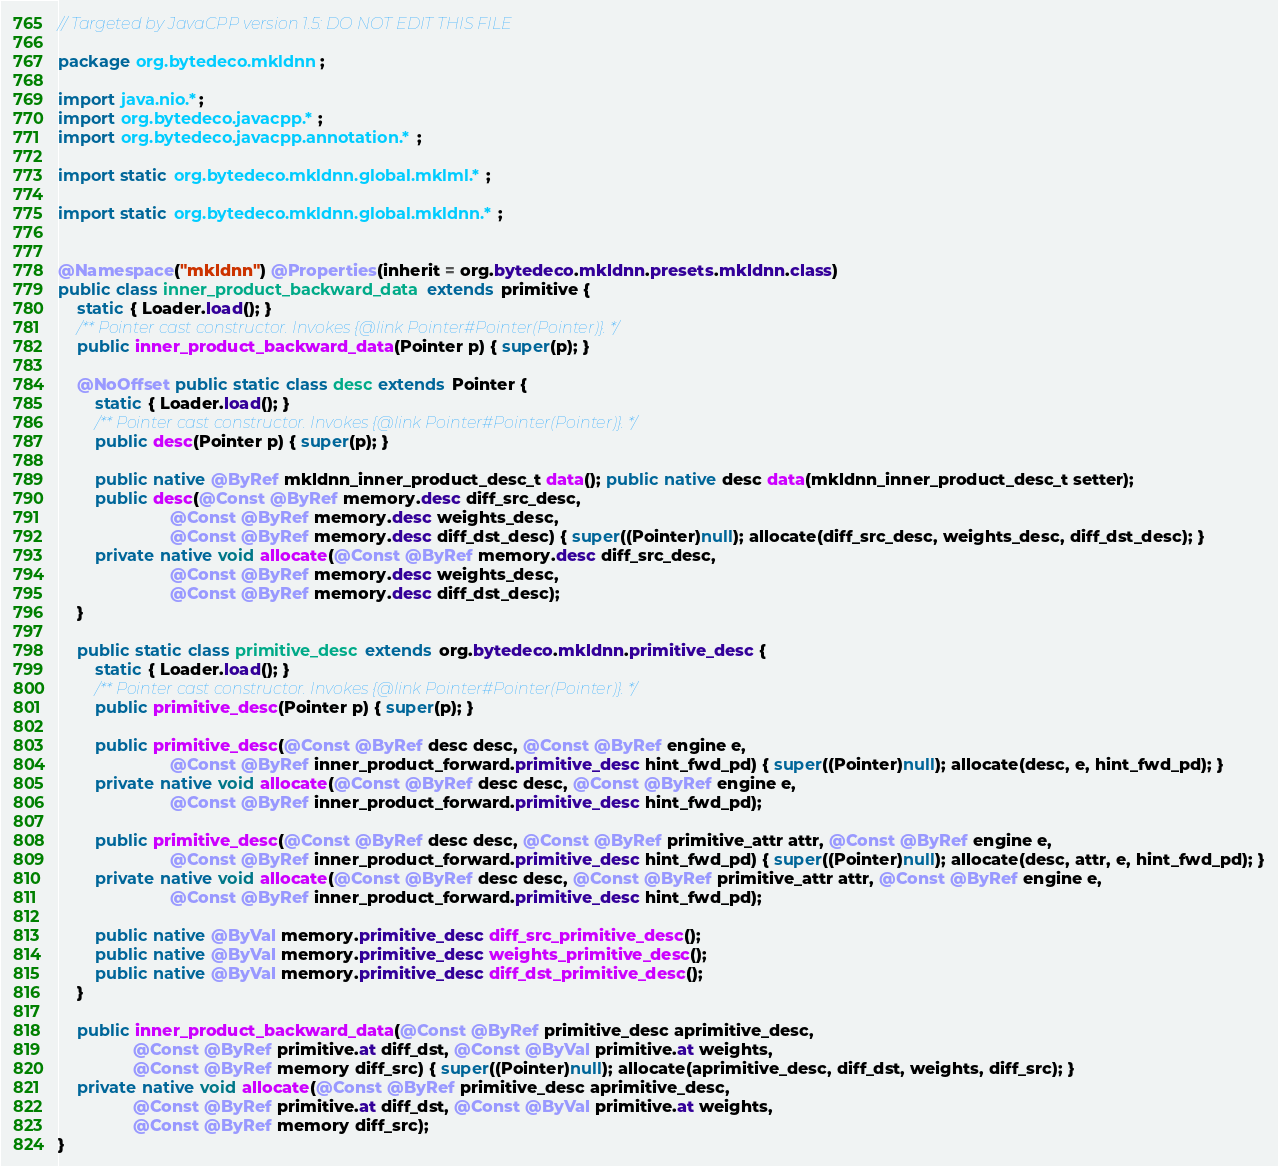<code> <loc_0><loc_0><loc_500><loc_500><_Java_>// Targeted by JavaCPP version 1.5: DO NOT EDIT THIS FILE

package org.bytedeco.mkldnn;

import java.nio.*;
import org.bytedeco.javacpp.*;
import org.bytedeco.javacpp.annotation.*;

import static org.bytedeco.mkldnn.global.mklml.*;

import static org.bytedeco.mkldnn.global.mkldnn.*;


@Namespace("mkldnn") @Properties(inherit = org.bytedeco.mkldnn.presets.mkldnn.class)
public class inner_product_backward_data extends primitive {
    static { Loader.load(); }
    /** Pointer cast constructor. Invokes {@link Pointer#Pointer(Pointer)}. */
    public inner_product_backward_data(Pointer p) { super(p); }

    @NoOffset public static class desc extends Pointer {
        static { Loader.load(); }
        /** Pointer cast constructor. Invokes {@link Pointer#Pointer(Pointer)}. */
        public desc(Pointer p) { super(p); }
    
        public native @ByRef mkldnn_inner_product_desc_t data(); public native desc data(mkldnn_inner_product_desc_t setter);
        public desc(@Const @ByRef memory.desc diff_src_desc,
                        @Const @ByRef memory.desc weights_desc,
                        @Const @ByRef memory.desc diff_dst_desc) { super((Pointer)null); allocate(diff_src_desc, weights_desc, diff_dst_desc); }
        private native void allocate(@Const @ByRef memory.desc diff_src_desc,
                        @Const @ByRef memory.desc weights_desc,
                        @Const @ByRef memory.desc diff_dst_desc);
    }

    public static class primitive_desc extends org.bytedeco.mkldnn.primitive_desc {
        static { Loader.load(); }
        /** Pointer cast constructor. Invokes {@link Pointer#Pointer(Pointer)}. */
        public primitive_desc(Pointer p) { super(p); }
    
        public primitive_desc(@Const @ByRef desc desc, @Const @ByRef engine e,
                        @Const @ByRef inner_product_forward.primitive_desc hint_fwd_pd) { super((Pointer)null); allocate(desc, e, hint_fwd_pd); }
        private native void allocate(@Const @ByRef desc desc, @Const @ByRef engine e,
                        @Const @ByRef inner_product_forward.primitive_desc hint_fwd_pd);

        public primitive_desc(@Const @ByRef desc desc, @Const @ByRef primitive_attr attr, @Const @ByRef engine e,
                        @Const @ByRef inner_product_forward.primitive_desc hint_fwd_pd) { super((Pointer)null); allocate(desc, attr, e, hint_fwd_pd); }
        private native void allocate(@Const @ByRef desc desc, @Const @ByRef primitive_attr attr, @Const @ByRef engine e,
                        @Const @ByRef inner_product_forward.primitive_desc hint_fwd_pd);

        public native @ByVal memory.primitive_desc diff_src_primitive_desc();
        public native @ByVal memory.primitive_desc weights_primitive_desc();
        public native @ByVal memory.primitive_desc diff_dst_primitive_desc();
    }

    public inner_product_backward_data(@Const @ByRef primitive_desc aprimitive_desc,
                @Const @ByRef primitive.at diff_dst, @Const @ByVal primitive.at weights,
                @Const @ByRef memory diff_src) { super((Pointer)null); allocate(aprimitive_desc, diff_dst, weights, diff_src); }
    private native void allocate(@Const @ByRef primitive_desc aprimitive_desc,
                @Const @ByRef primitive.at diff_dst, @Const @ByVal primitive.at weights,
                @Const @ByRef memory diff_src);
}
</code> 